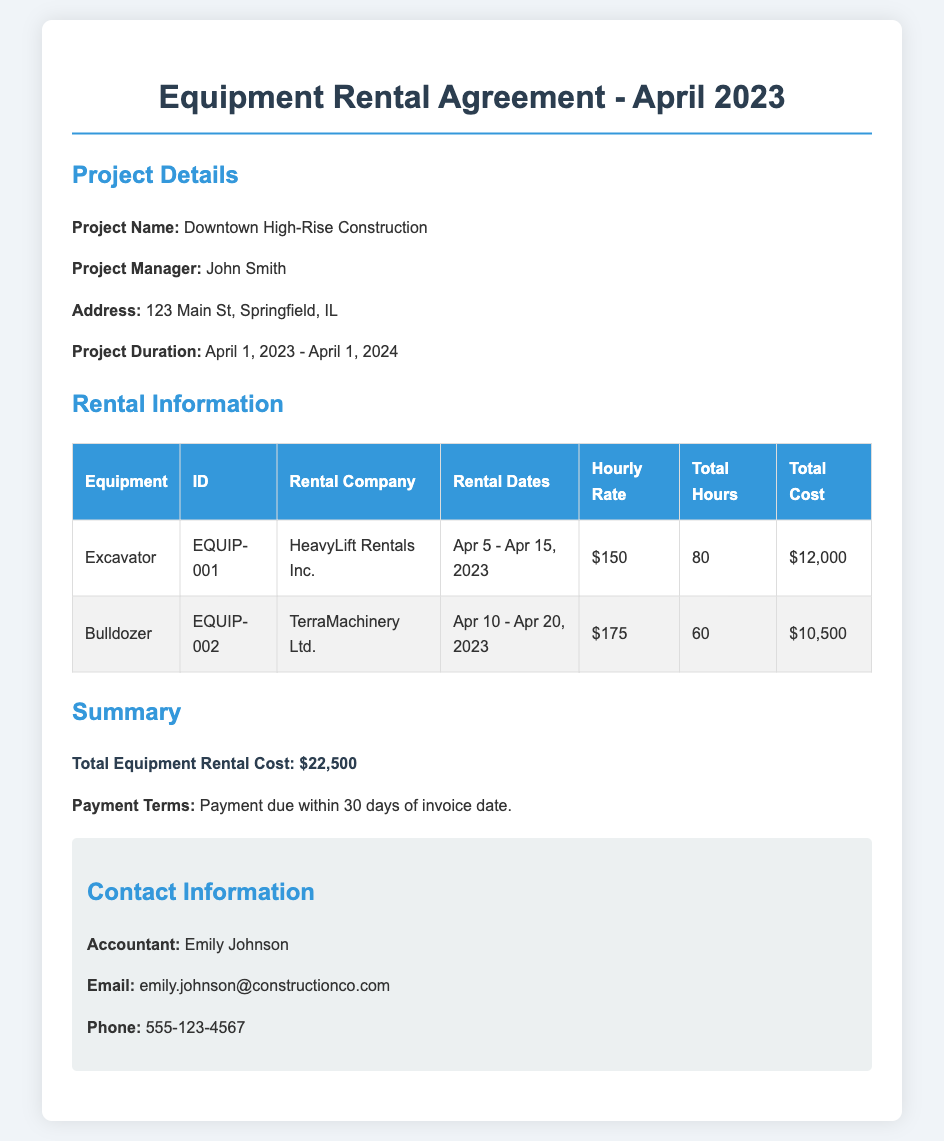What is the project name? The project name is mentioned in the project details section of the document.
Answer: Downtown High-Rise Construction Who is the project manager? The project manager's name is provided in the project details section.
Answer: John Smith What are the rental dates for the excavator? The rental dates for the excavator are specified in the rental information table.
Answer: Apr 5 - Apr 15, 2023 What is the hourly rate for the bulldozer? The hourly rate for the bulldozer is listed in the rental information table.
Answer: $175 What is the total equipment rental cost? The total equipment rental cost is summarized at the end of the rental information section.
Answer: $22,500 How many total hours was the excavator rented? The total hours for the excavator rental are stated in the rental information table.
Answer: 80 Which company rented the bulldozer? The rental company for the bulldozer can be found in the rental information table.
Answer: TerraMachinery Ltd What are the payment terms? The payment terms are clearly stated in the summary section of the document.
Answer: Payment due within 30 days of invoice date What is the contact email for the accountant? The accountant's email is specified in the contact information section.
Answer: emily.johnson@constructionco.com 